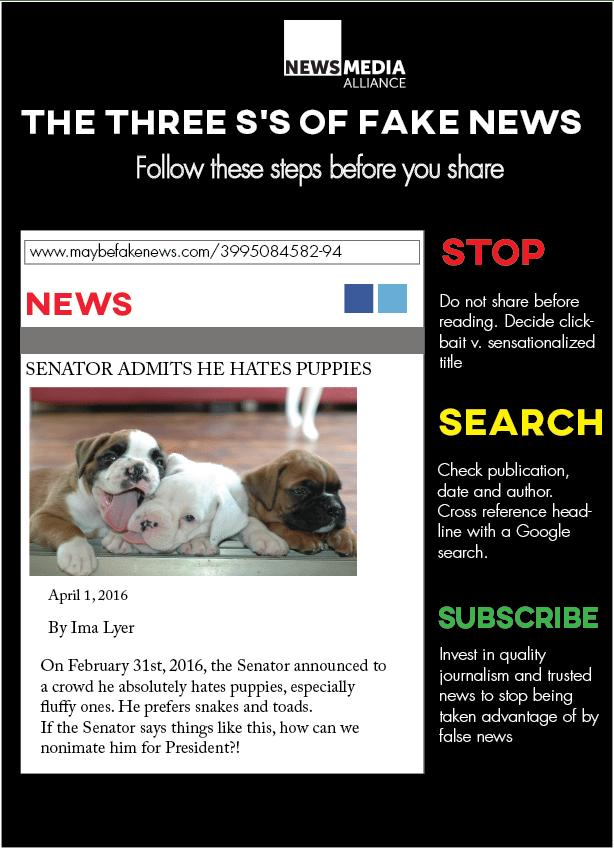Draw attention to some important aspects in this diagram. The subheading "search" is written in the color yellow. The subheading "stop" is written in red or yellow, but the color in which it is written is red. The color of the text in the main heading is white. The three "s's" of fake news according to the infographic are: Stop, Search, and Subscribe. 